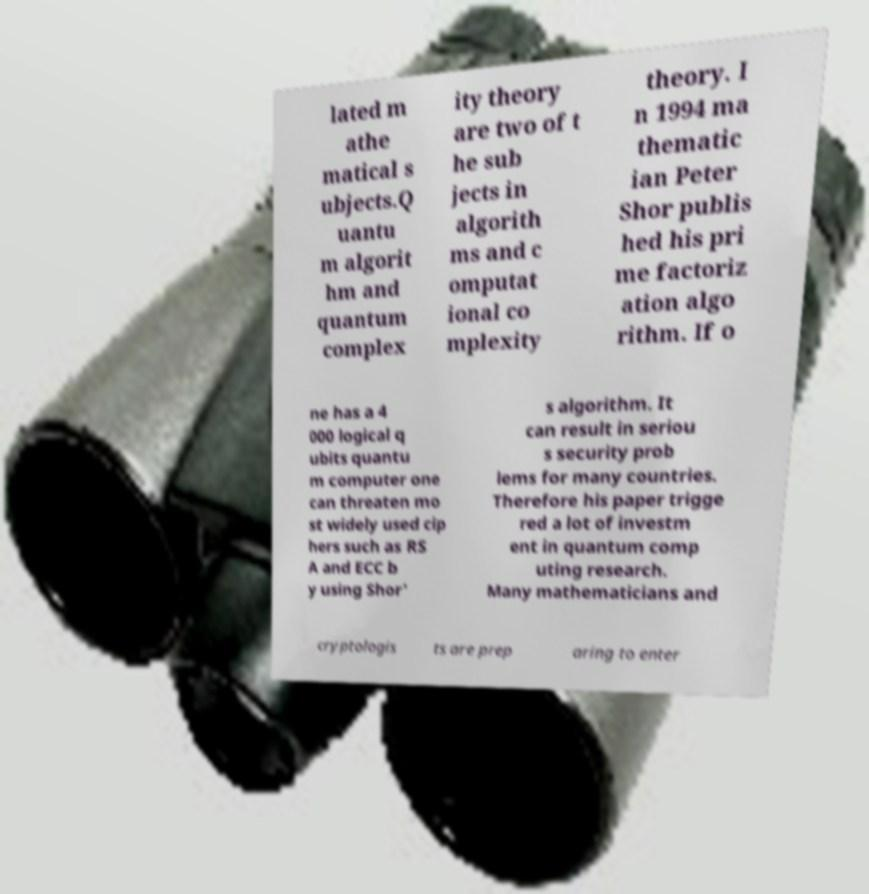I need the written content from this picture converted into text. Can you do that? lated m athe matical s ubjects.Q uantu m algorit hm and quantum complex ity theory are two of t he sub jects in algorith ms and c omputat ional co mplexity theory. I n 1994 ma thematic ian Peter Shor publis hed his pri me factoriz ation algo rithm. If o ne has a 4 000 logical q ubits quantu m computer one can threaten mo st widely used cip hers such as RS A and ECC b y using Shor' s algorithm. It can result in seriou s security prob lems for many countries. Therefore his paper trigge red a lot of investm ent in quantum comp uting research. Many mathematicians and cryptologis ts are prep aring to enter 